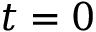Convert formula to latex. <formula><loc_0><loc_0><loc_500><loc_500>t = 0</formula> 